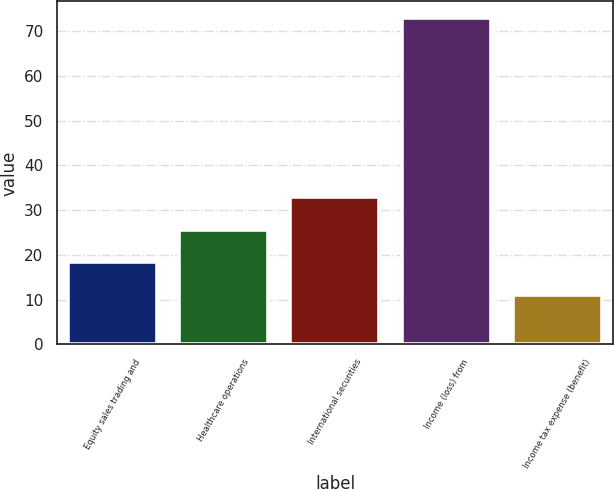Convert chart to OTSL. <chart><loc_0><loc_0><loc_500><loc_500><bar_chart><fcel>Equity sales trading and<fcel>Healthcare operations<fcel>International securities<fcel>Income (loss) from<fcel>Income tax expense (benefit)<nl><fcel>18.3<fcel>25.6<fcel>32.9<fcel>73<fcel>11<nl></chart> 